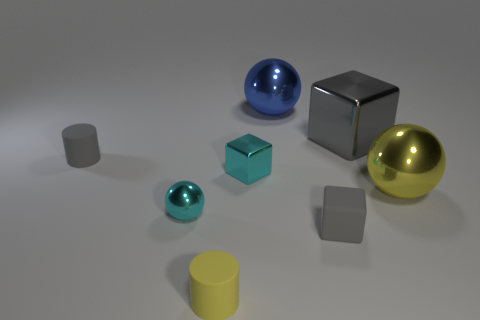Does the small matte cube have the same color as the big block?
Your answer should be compact. Yes. What size is the yellow metal thing that is the same shape as the big blue object?
Offer a terse response. Large. How many cyan balls have the same material as the yellow ball?
Your answer should be very brief. 1. What is the material of the gray cylinder?
Ensure brevity in your answer.  Rubber. What shape is the big thing that is in front of the tiny matte object behind the tiny sphere?
Give a very brief answer. Sphere. What is the shape of the matte object that is to the right of the small yellow rubber object?
Keep it short and to the point. Cube. How many small matte cylinders are the same color as the small rubber block?
Give a very brief answer. 1. What is the color of the matte block?
Keep it short and to the point. Gray. There is a yellow object that is to the left of the blue object; how many small objects are left of it?
Provide a succinct answer. 2. There is a cyan ball; does it have the same size as the shiny cube that is in front of the big cube?
Offer a terse response. Yes. 